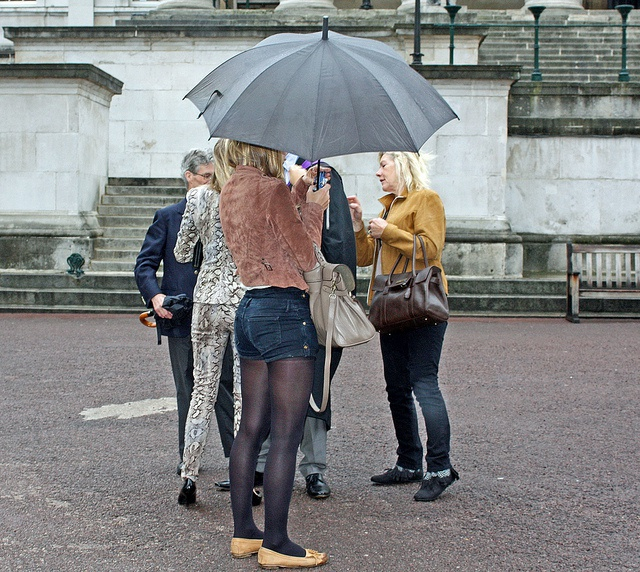Describe the objects in this image and their specific colors. I can see people in black and gray tones, umbrella in black, darkgray, and gray tones, people in black, gray, and tan tones, people in black, darkgray, lightgray, and gray tones, and people in black, gray, and darkgray tones in this image. 